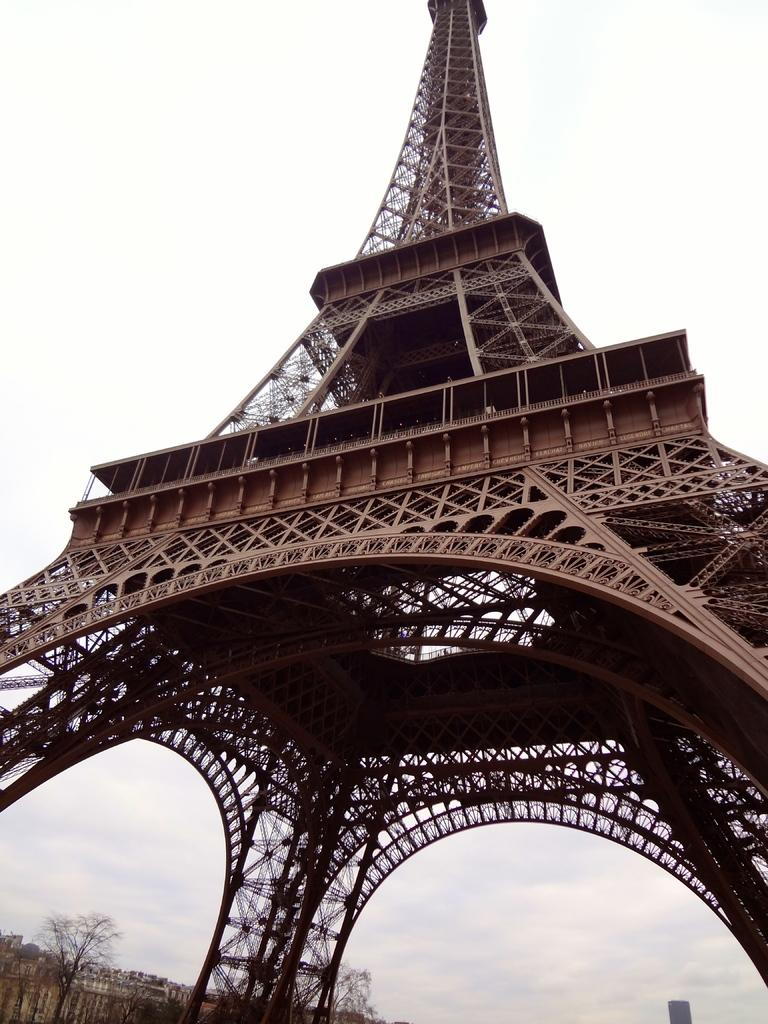What famous landmark can be seen in the image? The Eiffel Tower is visible in the image. What type of vegetation is present at the bottom of the image? There are trees at the bottom of the image. What can be seen in the background of the image? The sky is visible in the background of the image. What type of fork is being used to eat the trees in the image? There is no fork present in the image, and trees cannot be eaten. 